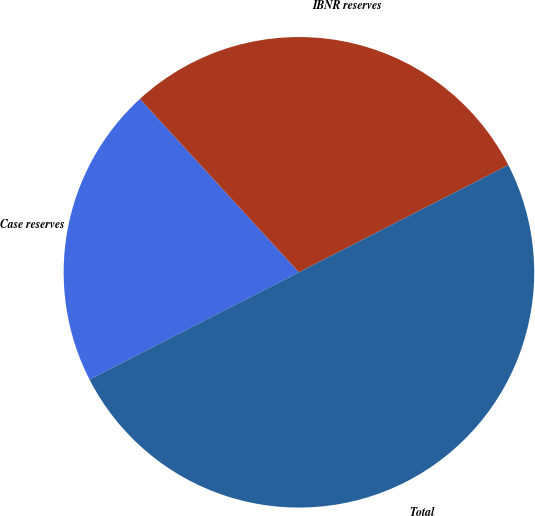Convert chart to OTSL. <chart><loc_0><loc_0><loc_500><loc_500><pie_chart><fcel>Case reserves<fcel>IBNR reserves<fcel>Total<nl><fcel>20.72%<fcel>29.28%<fcel>50.0%<nl></chart> 